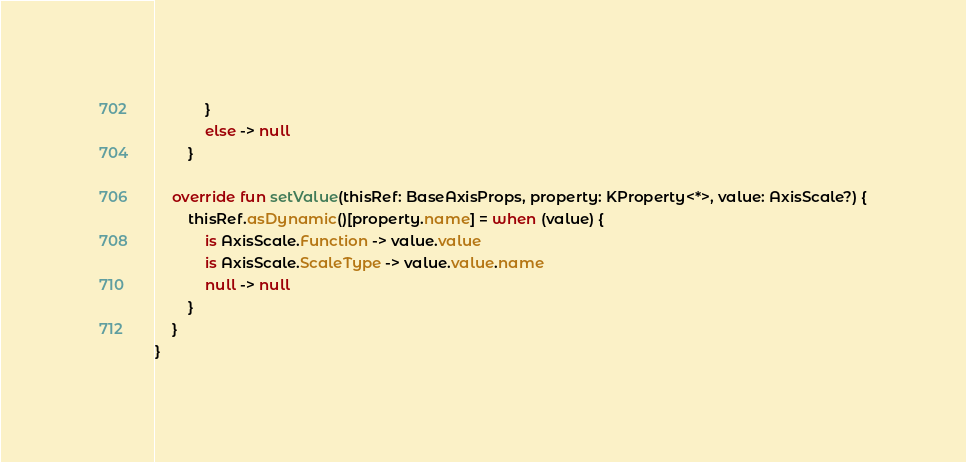Convert code to text. <code><loc_0><loc_0><loc_500><loc_500><_Kotlin_>            }
            else -> null
        }

    override fun setValue(thisRef: BaseAxisProps, property: KProperty<*>, value: AxisScale?) {
        thisRef.asDynamic()[property.name] = when (value) {
            is AxisScale.Function -> value.value
            is AxisScale.ScaleType -> value.value.name
            null -> null
        }
    }
}
</code> 